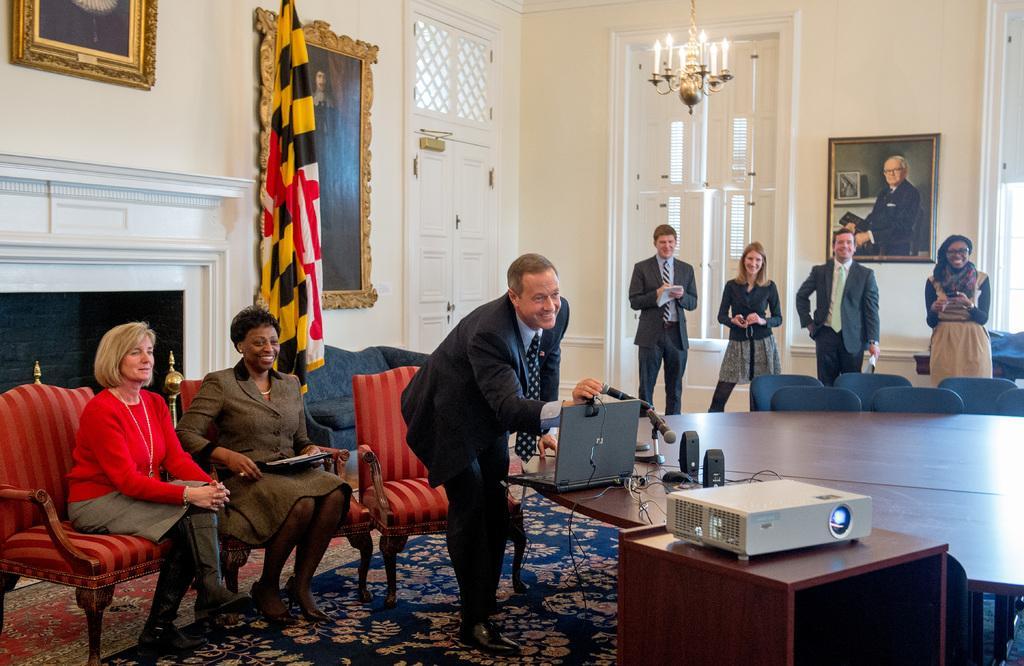Please provide a concise description of this image. There are five people standing and two women sitting on the chairs. This is a table with laptop,mike's,speakers,mouse placed on it. This is a projector. This looks like a flag hanging. These are the photo frames attached to the wall. This is a lamp hanging to the rooftop. I think this is the window. This is a door. This looks like a fireplace. This is a carpet on the floor. These are the empty chairs. 